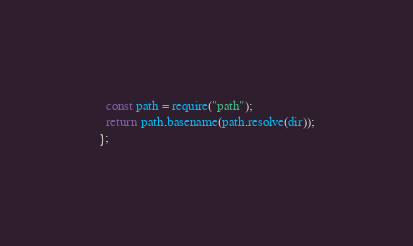<code> <loc_0><loc_0><loc_500><loc_500><_JavaScript_>  const path = require("path");
  return path.basename(path.resolve(dir));
};
</code> 